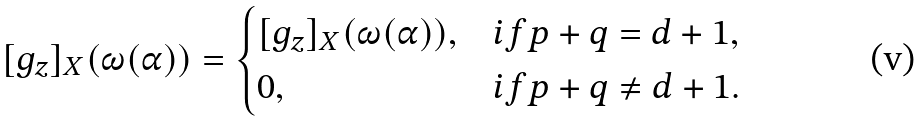Convert formula to latex. <formula><loc_0><loc_0><loc_500><loc_500>[ g _ { z } ] _ { X } ( \omega ( \alpha ) ) & = \begin{cases} [ g _ { z } ] _ { X } ( \omega ( \alpha ) ) , & i f p + q = d + 1 , \\ 0 , & i f p + q \neq d + 1 . \end{cases}</formula> 